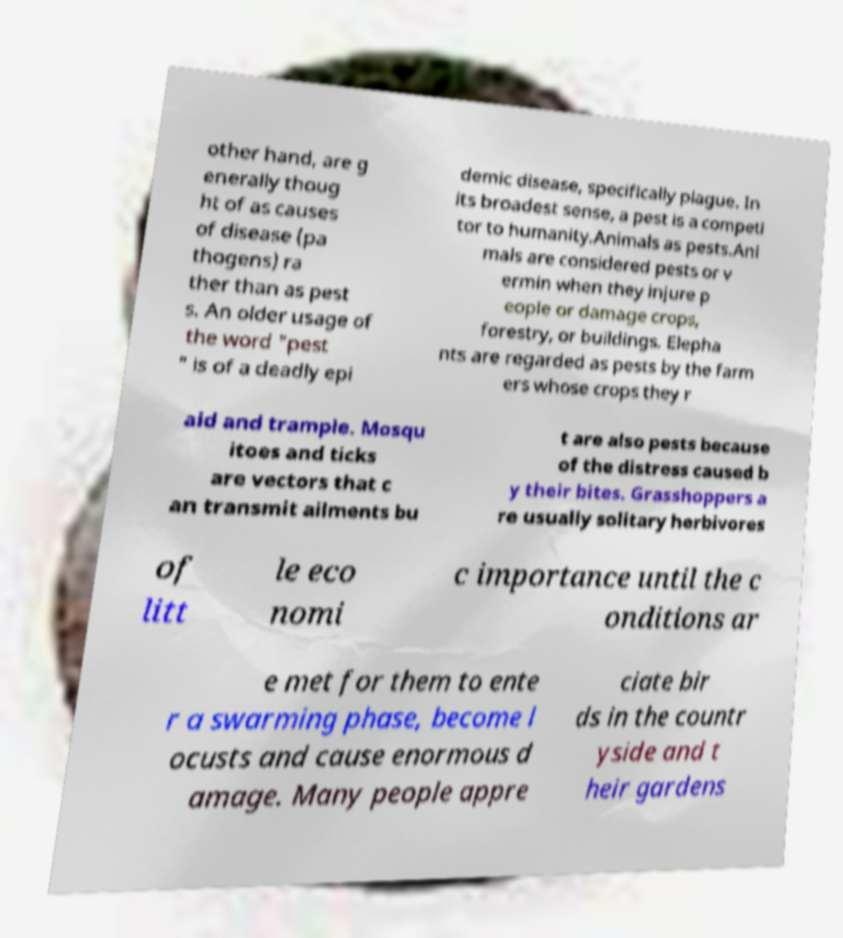Could you extract and type out the text from this image? other hand, are g enerally thoug ht of as causes of disease (pa thogens) ra ther than as pest s. An older usage of the word "pest " is of a deadly epi demic disease, specifically plague. In its broadest sense, a pest is a competi tor to humanity.Animals as pests.Ani mals are considered pests or v ermin when they injure p eople or damage crops, forestry, or buildings. Elepha nts are regarded as pests by the farm ers whose crops they r aid and trample. Mosqu itoes and ticks are vectors that c an transmit ailments bu t are also pests because of the distress caused b y their bites. Grasshoppers a re usually solitary herbivores of litt le eco nomi c importance until the c onditions ar e met for them to ente r a swarming phase, become l ocusts and cause enormous d amage. Many people appre ciate bir ds in the countr yside and t heir gardens 